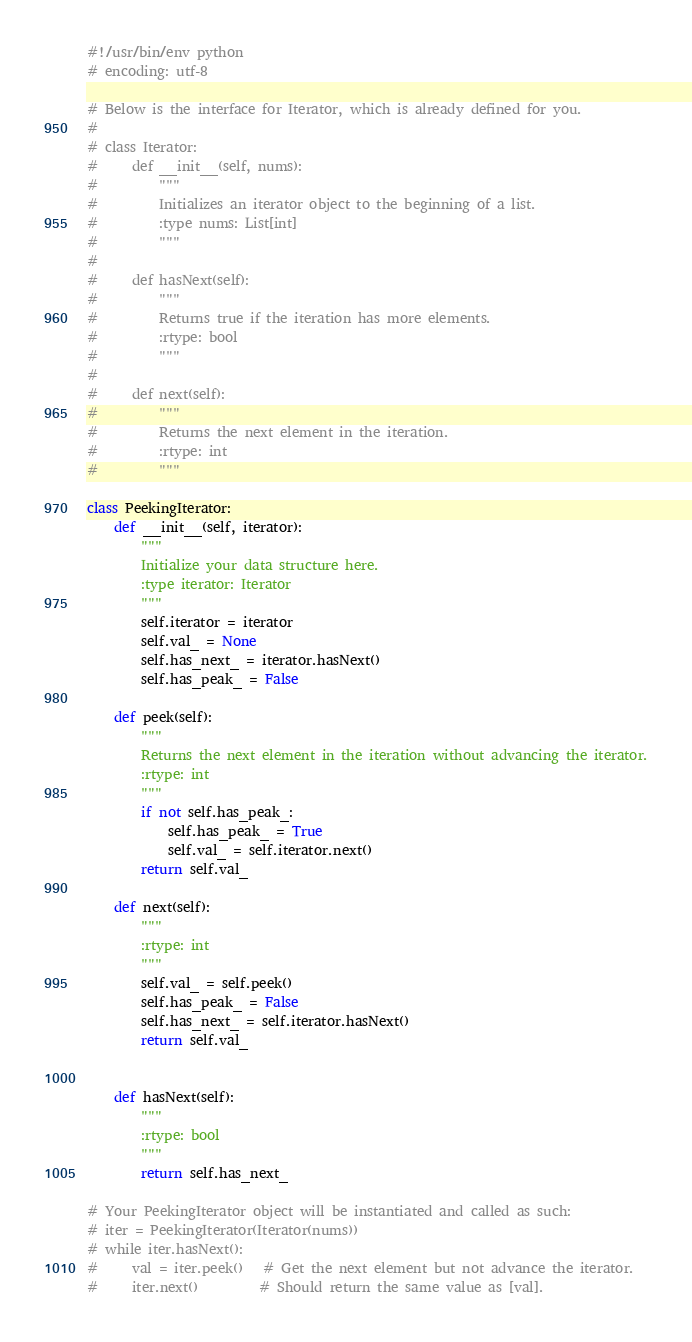Convert code to text. <code><loc_0><loc_0><loc_500><loc_500><_Python_>#!/usr/bin/env python
# encoding: utf-8

# Below is the interface for Iterator, which is already defined for you.
#
# class Iterator:
#     def __init__(self, nums):
#         """
#         Initializes an iterator object to the beginning of a list.
#         :type nums: List[int]
#         """
#
#     def hasNext(self):
#         """
#         Returns true if the iteration has more elements.
#         :rtype: bool
#         """
#
#     def next(self):
#         """
#         Returns the next element in the iteration.
#         :rtype: int
#         """

class PeekingIterator:
    def __init__(self, iterator):
        """
        Initialize your data structure here.
        :type iterator: Iterator
        """
        self.iterator = iterator
        self.val_ = None
        self.has_next_ = iterator.hasNext()
        self.has_peak_ = False

    def peek(self):
        """
        Returns the next element in the iteration without advancing the iterator.
        :rtype: int
        """
        if not self.has_peak_:
            self.has_peak_ = True
            self.val_ = self.iterator.next()
        return self.val_

    def next(self):
        """
        :rtype: int
        """
        self.val_ = self.peek()
        self.has_peak_ = False
        self.has_next_ = self.iterator.hasNext()
        return self.val_


    def hasNext(self):
        """
        :rtype: bool
        """
        return self.has_next_

# Your PeekingIterator object will be instantiated and called as such:
# iter = PeekingIterator(Iterator(nums))
# while iter.hasNext():
#     val = iter.peek()   # Get the next element but not advance the iterator.
#     iter.next()         # Should return the same value as [val].
</code> 